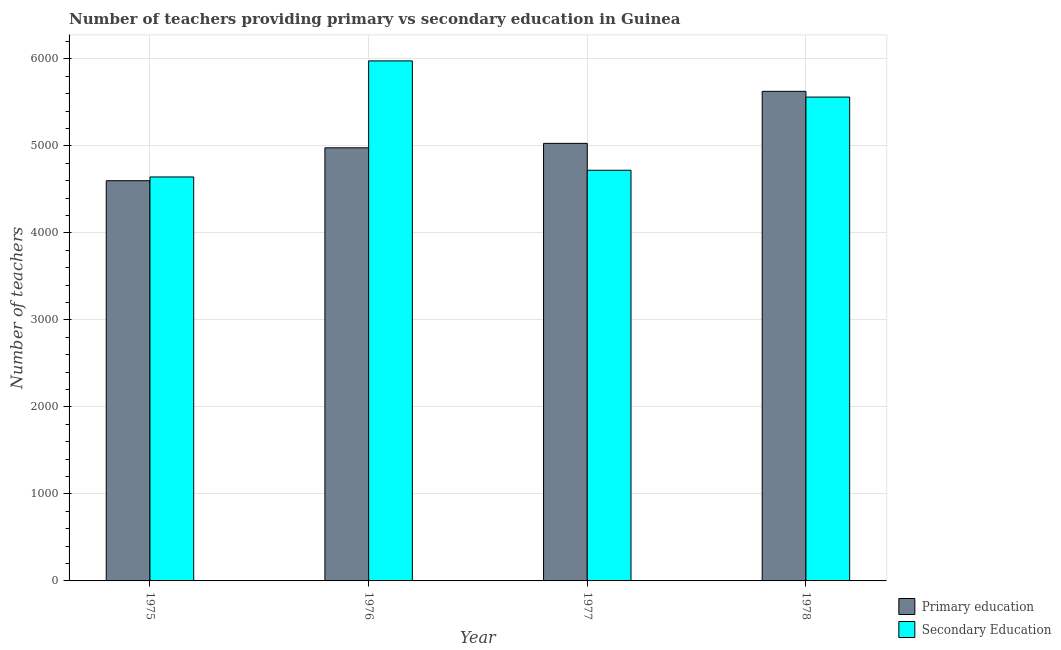How many different coloured bars are there?
Provide a short and direct response. 2. Are the number of bars on each tick of the X-axis equal?
Offer a terse response. Yes. How many bars are there on the 3rd tick from the right?
Offer a very short reply. 2. What is the label of the 2nd group of bars from the left?
Provide a short and direct response. 1976. What is the number of primary teachers in 1975?
Your answer should be very brief. 4599. Across all years, what is the maximum number of primary teachers?
Offer a terse response. 5626. Across all years, what is the minimum number of primary teachers?
Keep it short and to the point. 4599. In which year was the number of primary teachers maximum?
Make the answer very short. 1978. In which year was the number of primary teachers minimum?
Your answer should be very brief. 1975. What is the total number of secondary teachers in the graph?
Offer a very short reply. 2.09e+04. What is the difference between the number of secondary teachers in 1976 and that in 1978?
Keep it short and to the point. 416. What is the difference between the number of secondary teachers in 1978 and the number of primary teachers in 1976?
Your answer should be compact. -416. What is the average number of primary teachers per year?
Your answer should be very brief. 5057.5. In the year 1978, what is the difference between the number of primary teachers and number of secondary teachers?
Ensure brevity in your answer.  0. In how many years, is the number of primary teachers greater than 4800?
Your response must be concise. 3. What is the ratio of the number of primary teachers in 1976 to that in 1977?
Your answer should be compact. 0.99. Is the number of secondary teachers in 1975 less than that in 1978?
Make the answer very short. Yes. What is the difference between the highest and the second highest number of primary teachers?
Offer a very short reply. 598. What is the difference between the highest and the lowest number of secondary teachers?
Your answer should be very brief. 1334. Is the sum of the number of secondary teachers in 1977 and 1978 greater than the maximum number of primary teachers across all years?
Offer a terse response. Yes. What does the 2nd bar from the left in 1978 represents?
Offer a very short reply. Secondary Education. What does the 1st bar from the right in 1975 represents?
Your response must be concise. Secondary Education. Are all the bars in the graph horizontal?
Offer a terse response. No. What is the difference between two consecutive major ticks on the Y-axis?
Your answer should be compact. 1000. Does the graph contain grids?
Your answer should be very brief. Yes. Where does the legend appear in the graph?
Provide a short and direct response. Bottom right. How are the legend labels stacked?
Provide a succinct answer. Vertical. What is the title of the graph?
Provide a short and direct response. Number of teachers providing primary vs secondary education in Guinea. Does "Health Care" appear as one of the legend labels in the graph?
Offer a very short reply. No. What is the label or title of the X-axis?
Your answer should be compact. Year. What is the label or title of the Y-axis?
Give a very brief answer. Number of teachers. What is the Number of teachers in Primary education in 1975?
Make the answer very short. 4599. What is the Number of teachers of Secondary Education in 1975?
Ensure brevity in your answer.  4642. What is the Number of teachers of Primary education in 1976?
Offer a terse response. 4977. What is the Number of teachers in Secondary Education in 1976?
Provide a short and direct response. 5976. What is the Number of teachers in Primary education in 1977?
Provide a short and direct response. 5028. What is the Number of teachers in Secondary Education in 1977?
Your response must be concise. 4719. What is the Number of teachers in Primary education in 1978?
Ensure brevity in your answer.  5626. What is the Number of teachers in Secondary Education in 1978?
Your answer should be compact. 5560. Across all years, what is the maximum Number of teachers in Primary education?
Give a very brief answer. 5626. Across all years, what is the maximum Number of teachers in Secondary Education?
Your answer should be very brief. 5976. Across all years, what is the minimum Number of teachers in Primary education?
Offer a terse response. 4599. Across all years, what is the minimum Number of teachers in Secondary Education?
Make the answer very short. 4642. What is the total Number of teachers of Primary education in the graph?
Provide a short and direct response. 2.02e+04. What is the total Number of teachers of Secondary Education in the graph?
Make the answer very short. 2.09e+04. What is the difference between the Number of teachers of Primary education in 1975 and that in 1976?
Ensure brevity in your answer.  -378. What is the difference between the Number of teachers in Secondary Education in 1975 and that in 1976?
Give a very brief answer. -1334. What is the difference between the Number of teachers of Primary education in 1975 and that in 1977?
Provide a succinct answer. -429. What is the difference between the Number of teachers in Secondary Education in 1975 and that in 1977?
Provide a succinct answer. -77. What is the difference between the Number of teachers in Primary education in 1975 and that in 1978?
Make the answer very short. -1027. What is the difference between the Number of teachers in Secondary Education in 1975 and that in 1978?
Keep it short and to the point. -918. What is the difference between the Number of teachers of Primary education in 1976 and that in 1977?
Offer a terse response. -51. What is the difference between the Number of teachers of Secondary Education in 1976 and that in 1977?
Your response must be concise. 1257. What is the difference between the Number of teachers of Primary education in 1976 and that in 1978?
Make the answer very short. -649. What is the difference between the Number of teachers in Secondary Education in 1976 and that in 1978?
Your answer should be very brief. 416. What is the difference between the Number of teachers in Primary education in 1977 and that in 1978?
Offer a very short reply. -598. What is the difference between the Number of teachers of Secondary Education in 1977 and that in 1978?
Offer a terse response. -841. What is the difference between the Number of teachers of Primary education in 1975 and the Number of teachers of Secondary Education in 1976?
Your answer should be compact. -1377. What is the difference between the Number of teachers in Primary education in 1975 and the Number of teachers in Secondary Education in 1977?
Ensure brevity in your answer.  -120. What is the difference between the Number of teachers in Primary education in 1975 and the Number of teachers in Secondary Education in 1978?
Your answer should be compact. -961. What is the difference between the Number of teachers of Primary education in 1976 and the Number of teachers of Secondary Education in 1977?
Offer a terse response. 258. What is the difference between the Number of teachers of Primary education in 1976 and the Number of teachers of Secondary Education in 1978?
Give a very brief answer. -583. What is the difference between the Number of teachers of Primary education in 1977 and the Number of teachers of Secondary Education in 1978?
Give a very brief answer. -532. What is the average Number of teachers in Primary education per year?
Provide a succinct answer. 5057.5. What is the average Number of teachers of Secondary Education per year?
Provide a short and direct response. 5224.25. In the year 1975, what is the difference between the Number of teachers of Primary education and Number of teachers of Secondary Education?
Your answer should be compact. -43. In the year 1976, what is the difference between the Number of teachers of Primary education and Number of teachers of Secondary Education?
Keep it short and to the point. -999. In the year 1977, what is the difference between the Number of teachers of Primary education and Number of teachers of Secondary Education?
Your answer should be very brief. 309. What is the ratio of the Number of teachers in Primary education in 1975 to that in 1976?
Offer a terse response. 0.92. What is the ratio of the Number of teachers in Secondary Education in 1975 to that in 1976?
Your answer should be compact. 0.78. What is the ratio of the Number of teachers of Primary education in 1975 to that in 1977?
Provide a succinct answer. 0.91. What is the ratio of the Number of teachers in Secondary Education in 1975 to that in 1977?
Provide a succinct answer. 0.98. What is the ratio of the Number of teachers of Primary education in 1975 to that in 1978?
Keep it short and to the point. 0.82. What is the ratio of the Number of teachers of Secondary Education in 1975 to that in 1978?
Provide a succinct answer. 0.83. What is the ratio of the Number of teachers in Primary education in 1976 to that in 1977?
Your response must be concise. 0.99. What is the ratio of the Number of teachers of Secondary Education in 1976 to that in 1977?
Your response must be concise. 1.27. What is the ratio of the Number of teachers of Primary education in 1976 to that in 1978?
Offer a terse response. 0.88. What is the ratio of the Number of teachers of Secondary Education in 1976 to that in 1978?
Offer a very short reply. 1.07. What is the ratio of the Number of teachers in Primary education in 1977 to that in 1978?
Provide a short and direct response. 0.89. What is the ratio of the Number of teachers in Secondary Education in 1977 to that in 1978?
Your answer should be compact. 0.85. What is the difference between the highest and the second highest Number of teachers of Primary education?
Your answer should be very brief. 598. What is the difference between the highest and the second highest Number of teachers of Secondary Education?
Keep it short and to the point. 416. What is the difference between the highest and the lowest Number of teachers of Primary education?
Give a very brief answer. 1027. What is the difference between the highest and the lowest Number of teachers in Secondary Education?
Your answer should be compact. 1334. 